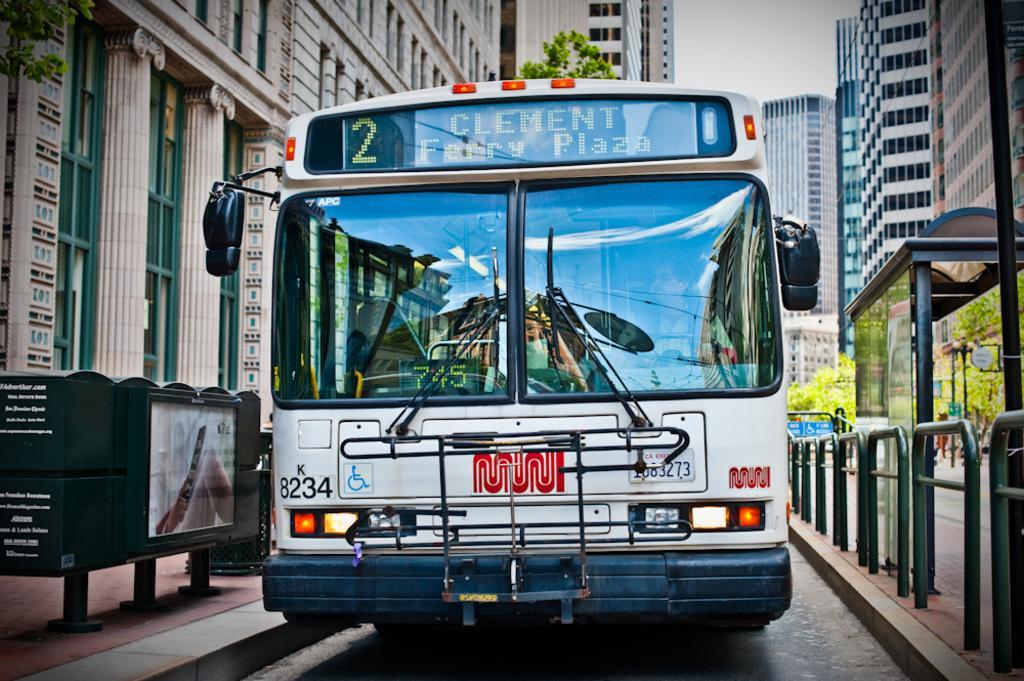How would you summarize this image in a sentence or two? In the picture there is a bus beside the bus bay and around that bus there are many tall buildings. 